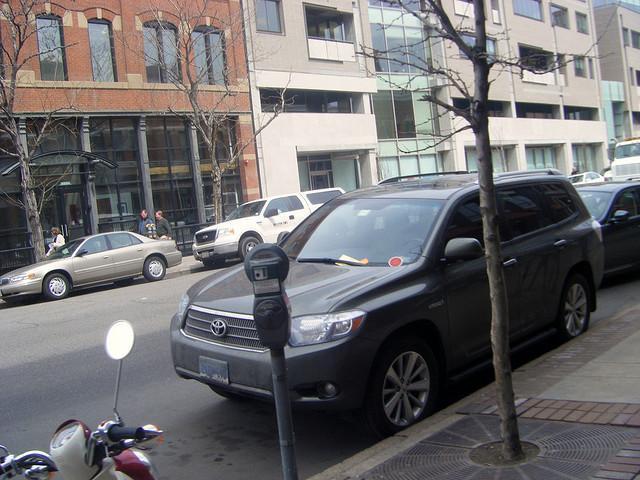How many cars are there?
Give a very brief answer. 4. How many boats do you see?
Give a very brief answer. 0. 